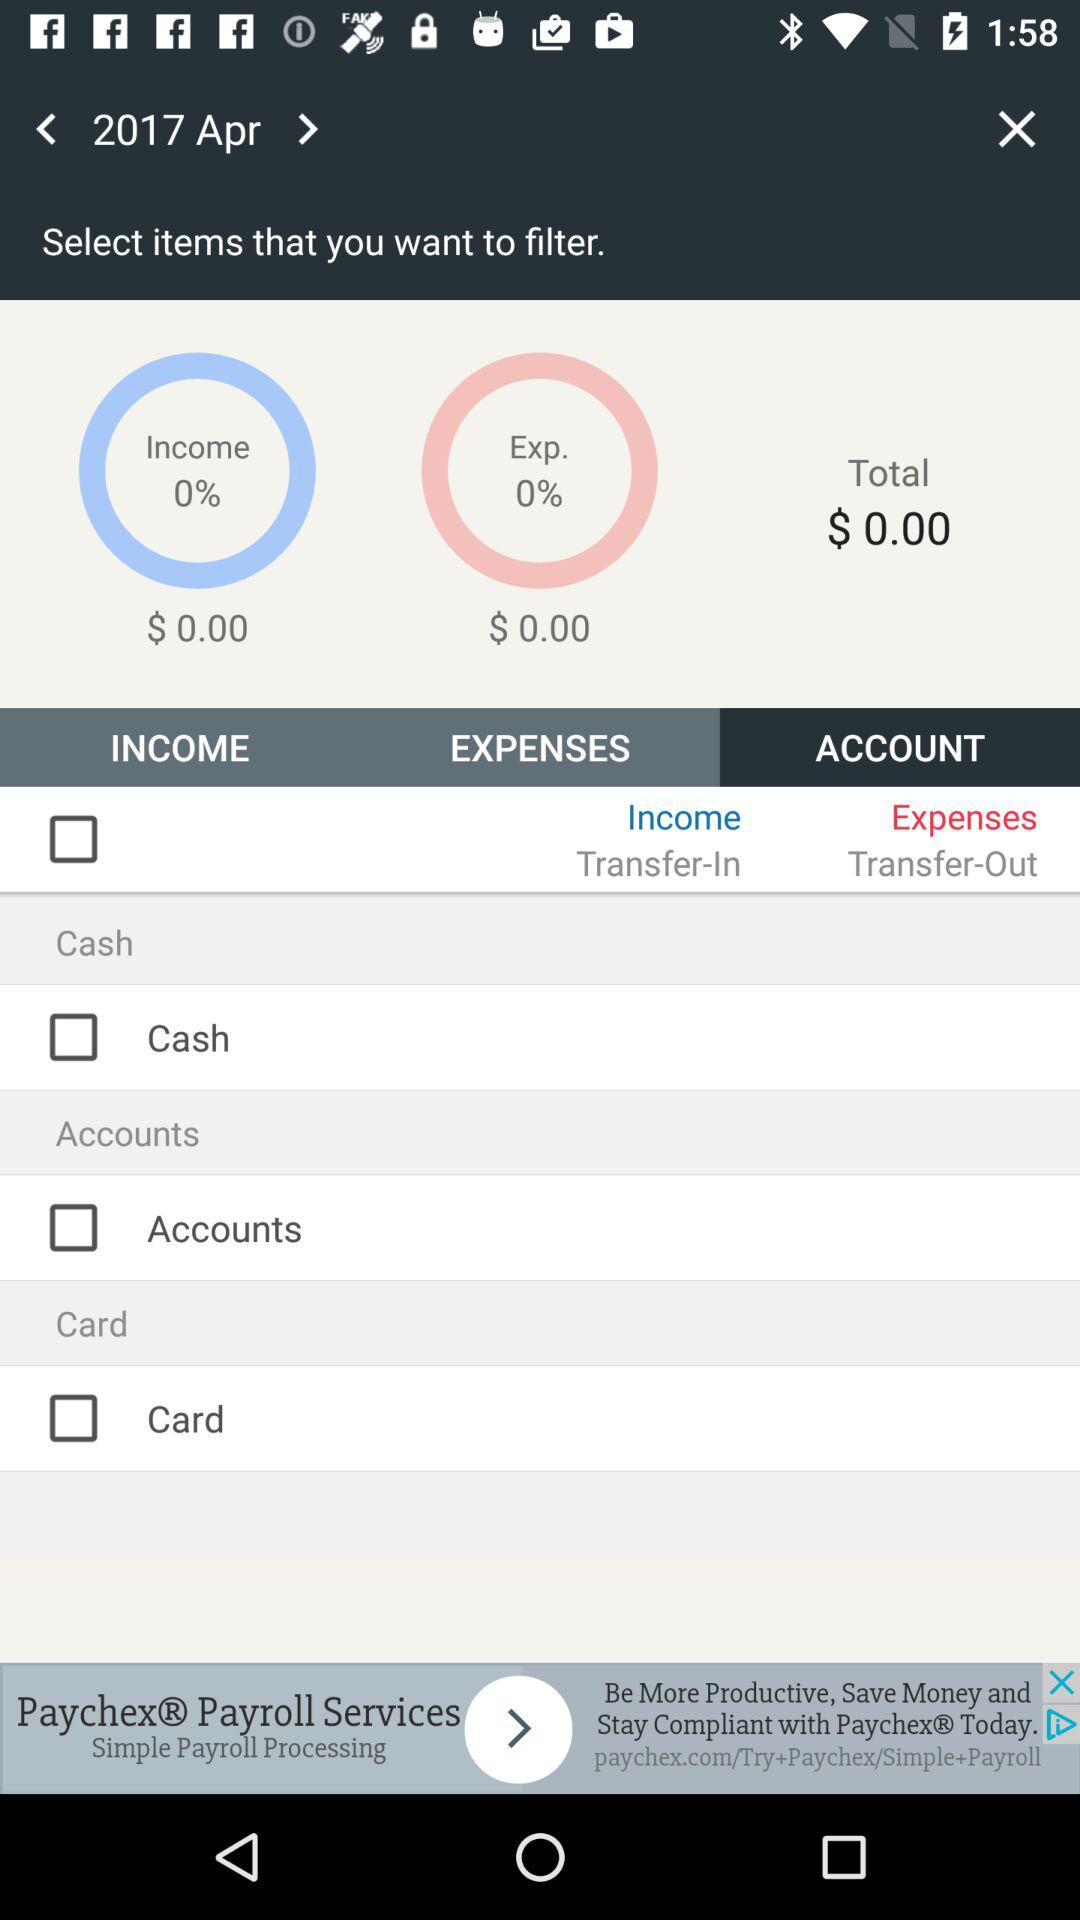How much income percentage is there? There is a 0 percentage of income. 